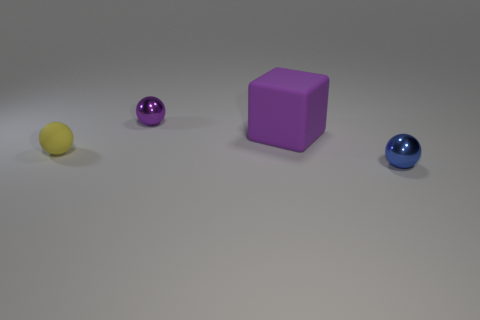Subtract all small matte balls. How many balls are left? 2 Add 2 big matte objects. How many objects exist? 6 Add 2 green cylinders. How many green cylinders exist? 2 Subtract 0 cyan cylinders. How many objects are left? 4 Subtract all spheres. How many objects are left? 1 Subtract all cyan balls. Subtract all cyan blocks. How many balls are left? 3 Subtract all small purple spheres. Subtract all tiny purple metallic spheres. How many objects are left? 2 Add 2 yellow objects. How many yellow objects are left? 3 